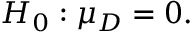<formula> <loc_0><loc_0><loc_500><loc_500>H _ { 0 } \colon \mu _ { D } = 0 .</formula> 